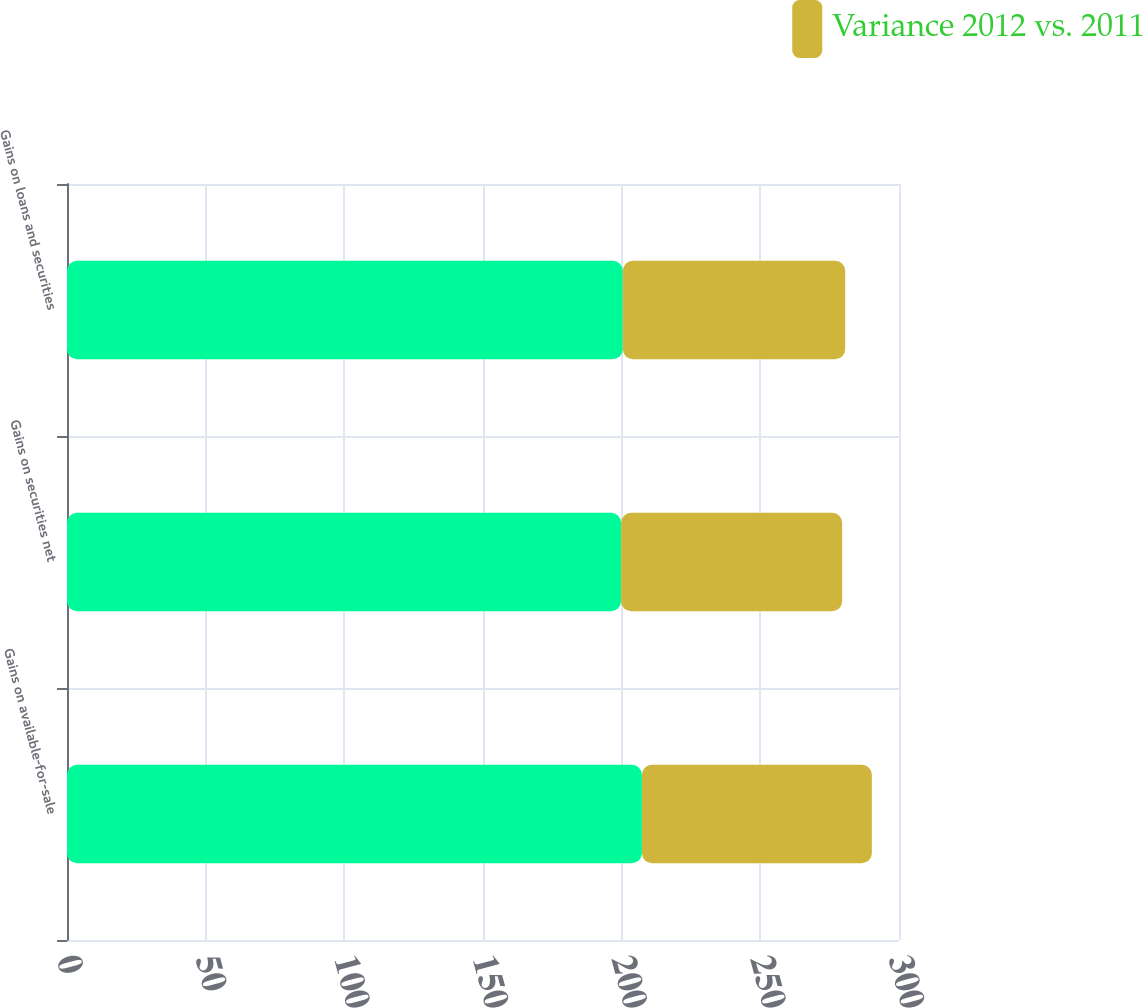Convert chart. <chart><loc_0><loc_0><loc_500><loc_500><stacked_bar_chart><ecel><fcel>Gains on available-for-sale<fcel>Gains on securities net<fcel>Gains on loans and securities<nl><fcel>nan<fcel>207.3<fcel>199.8<fcel>200.4<nl><fcel>Variance 2012 vs. 2011<fcel>82.9<fcel>79.7<fcel>80.2<nl></chart> 